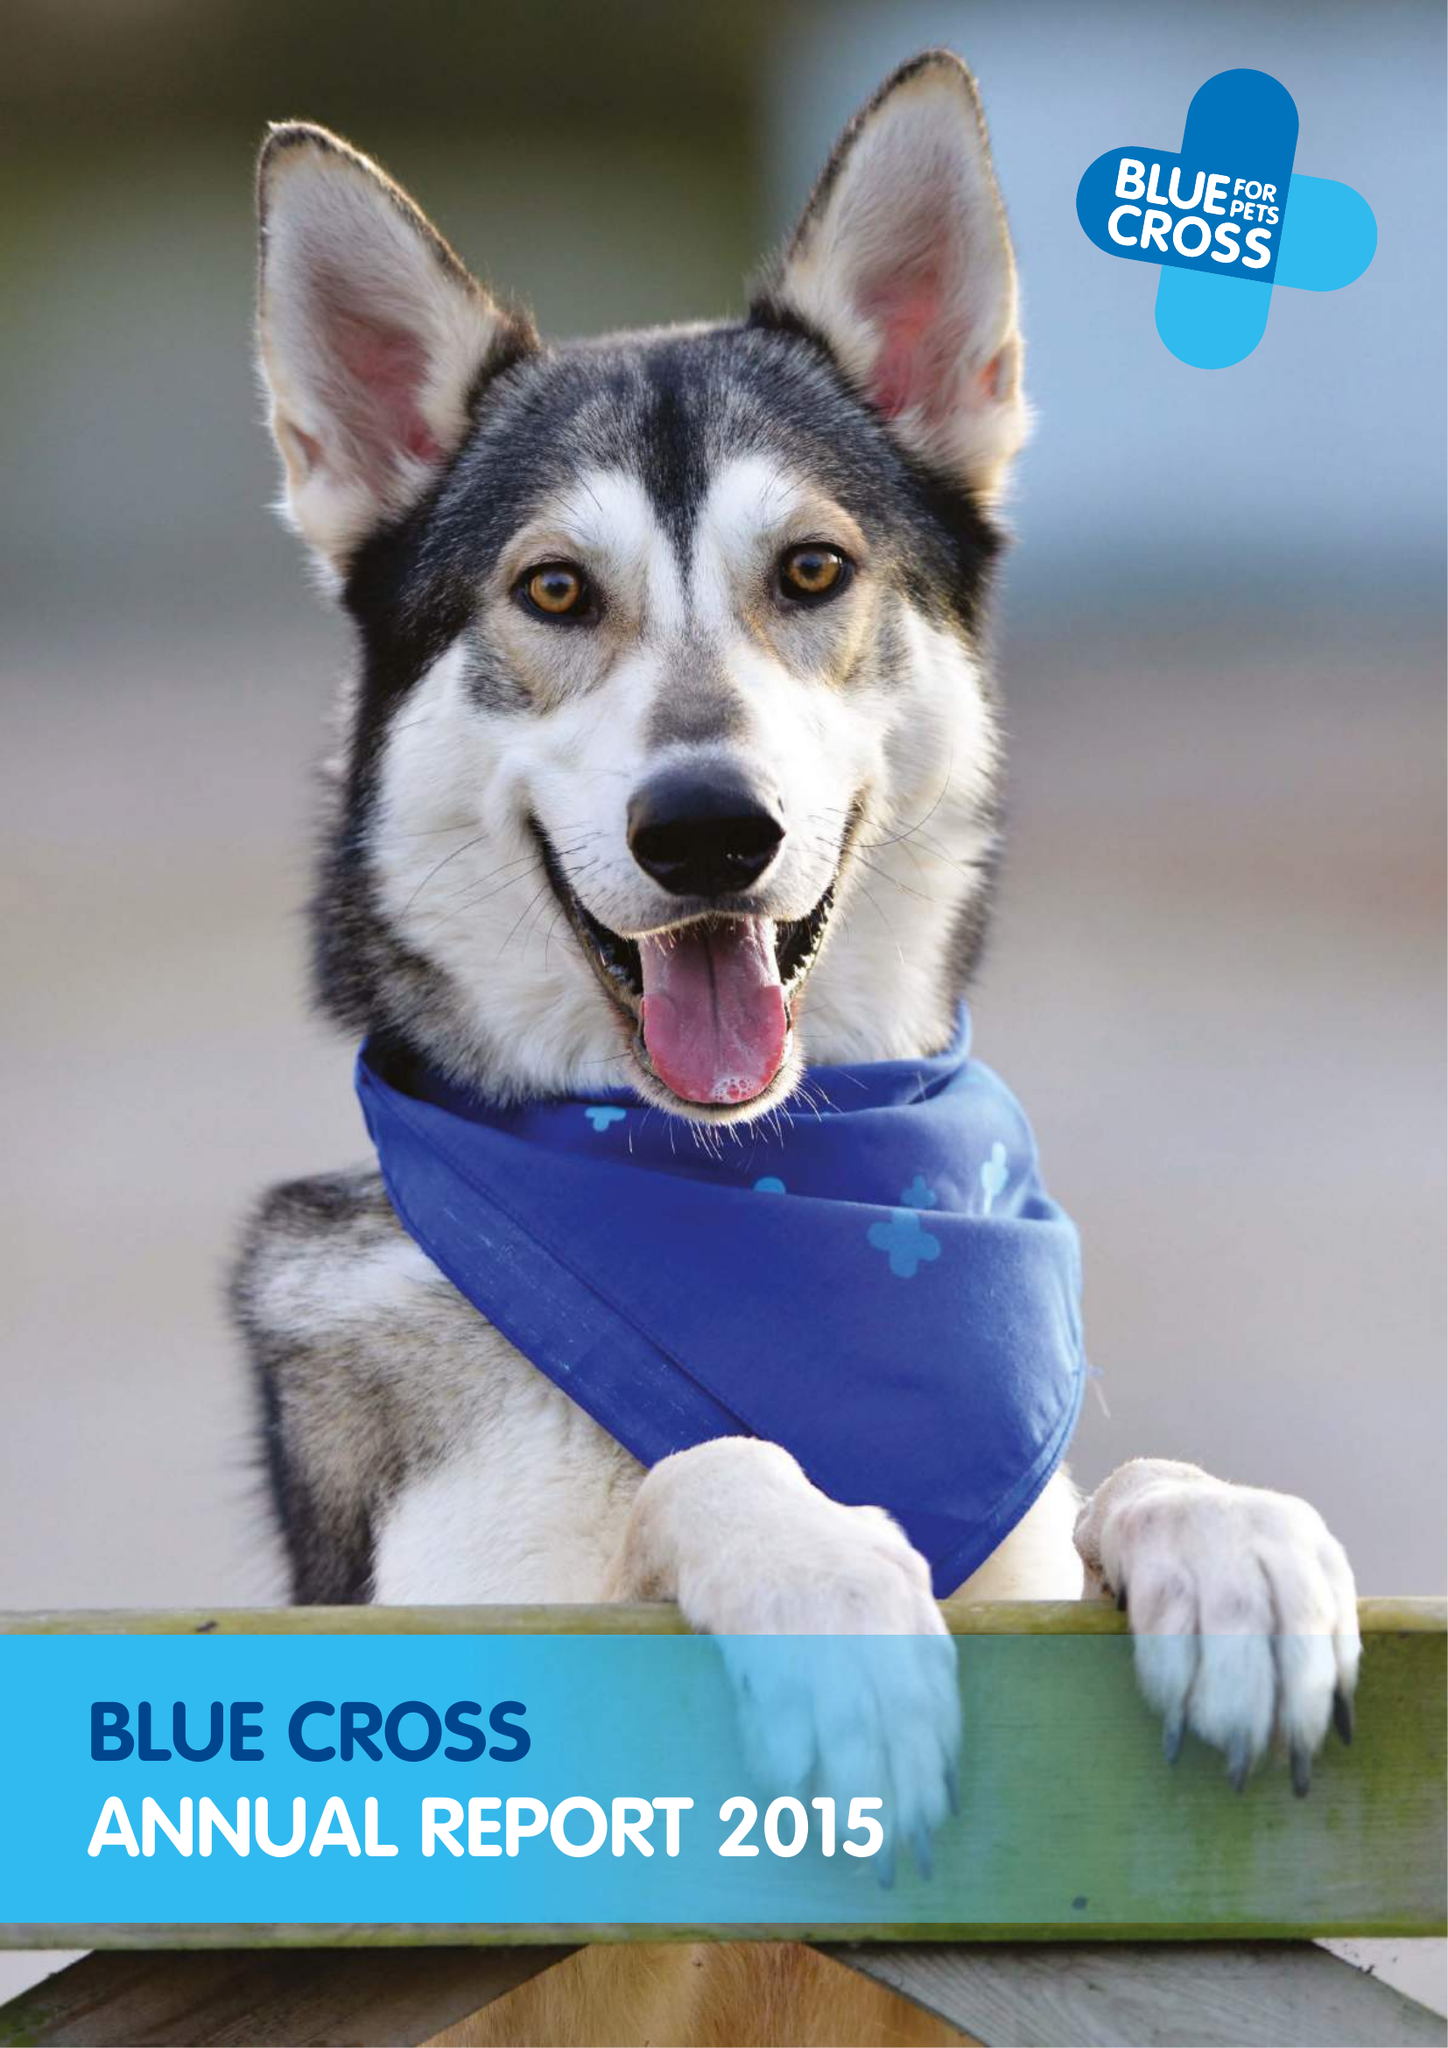What is the value for the report_date?
Answer the question using a single word or phrase. 2015-12-31 